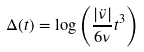Convert formula to latex. <formula><loc_0><loc_0><loc_500><loc_500>\Delta ( t ) = \log \left ( \frac { | \ddot { \nu } | } { 6 \nu } t ^ { 3 } \right )</formula> 